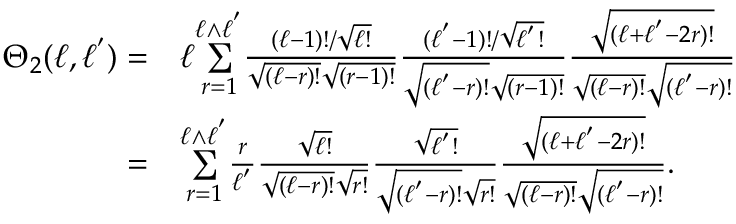<formula> <loc_0><loc_0><loc_500><loc_500>\begin{array} { r l } { \Theta _ { 2 } ( \ell , \ell ^ { ^ { \prime } } ) = } & { \ell \overset { \ell \wedge \ell ^ { ^ { \prime } } } { \underset { r = 1 } { \sum } } \frac { ( \ell - 1 ) ! / \sqrt { \ell ! } } { \sqrt { ( \ell - r ) ! } \sqrt { ( r - 1 ) ! } } \frac { ( \ell ^ { ^ { \prime } } - 1 ) ! / \sqrt { \ell ^ { ^ { \prime } } ! } } { \sqrt { ( \ell ^ { ^ { \prime } } - r ) ! } \sqrt { ( r - 1 ) ! } } \frac { \sqrt { ( \ell + \ell ^ { ^ { \prime } } - 2 r ) ! } } { \sqrt { ( \ell - r ) ! } \sqrt { ( \ell ^ { ^ { \prime } } - r ) ! } } } \\ { = } & { \overset { \ell \wedge \ell ^ { ^ { \prime } } } { \underset { r = 1 } { \sum } } \frac { r } { \ell ^ { ^ { \prime } } } \frac { \sqrt { \ell ! } } { \sqrt { ( \ell - r ) ! } \sqrt { r ! } } \frac { \sqrt { \ell ^ { ^ { \prime } } ! } } { \sqrt { ( \ell ^ { ^ { \prime } } - r ) ! } \sqrt { r ! } } \frac { \sqrt { ( \ell + \ell ^ { ^ { \prime } } - 2 r ) ! } } { \sqrt { ( \ell - r ) ! } \sqrt { ( \ell ^ { ^ { \prime } } - r ) ! } } . } \end{array}</formula> 